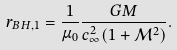<formula> <loc_0><loc_0><loc_500><loc_500>r _ { B H , 1 } = \frac { 1 } { \mu _ { 0 } } \frac { G M } { c _ { \infty } ^ { 2 } ( 1 + { \mathcal { M } } ^ { 2 } ) } .</formula> 